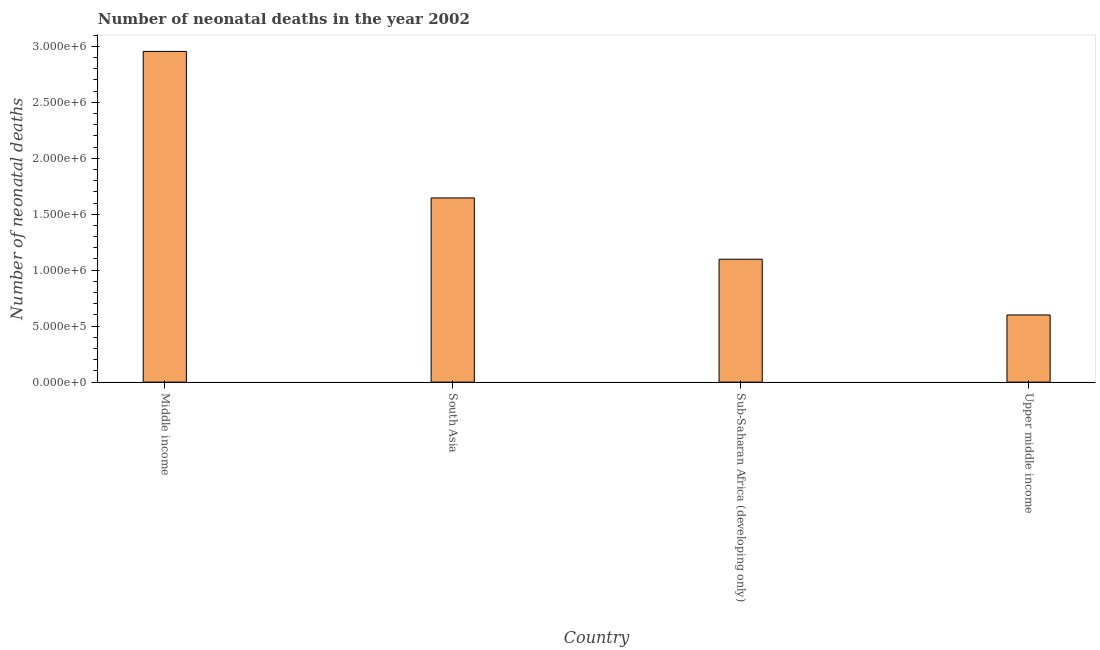Does the graph contain grids?
Your answer should be very brief. No. What is the title of the graph?
Your answer should be compact. Number of neonatal deaths in the year 2002. What is the label or title of the X-axis?
Your answer should be compact. Country. What is the label or title of the Y-axis?
Make the answer very short. Number of neonatal deaths. What is the number of neonatal deaths in Sub-Saharan Africa (developing only)?
Make the answer very short. 1.10e+06. Across all countries, what is the maximum number of neonatal deaths?
Offer a terse response. 2.95e+06. Across all countries, what is the minimum number of neonatal deaths?
Offer a very short reply. 6.00e+05. In which country was the number of neonatal deaths minimum?
Give a very brief answer. Upper middle income. What is the sum of the number of neonatal deaths?
Your response must be concise. 6.30e+06. What is the difference between the number of neonatal deaths in Middle income and Upper middle income?
Give a very brief answer. 2.35e+06. What is the average number of neonatal deaths per country?
Provide a succinct answer. 1.57e+06. What is the median number of neonatal deaths?
Provide a succinct answer. 1.37e+06. What is the ratio of the number of neonatal deaths in Middle income to that in South Asia?
Make the answer very short. 1.8. Is the number of neonatal deaths in Middle income less than that in Upper middle income?
Offer a terse response. No. Is the difference between the number of neonatal deaths in Sub-Saharan Africa (developing only) and Upper middle income greater than the difference between any two countries?
Keep it short and to the point. No. What is the difference between the highest and the second highest number of neonatal deaths?
Your response must be concise. 1.31e+06. What is the difference between the highest and the lowest number of neonatal deaths?
Provide a succinct answer. 2.35e+06. Are all the bars in the graph horizontal?
Your answer should be compact. No. How many countries are there in the graph?
Give a very brief answer. 4. What is the difference between two consecutive major ticks on the Y-axis?
Make the answer very short. 5.00e+05. Are the values on the major ticks of Y-axis written in scientific E-notation?
Ensure brevity in your answer.  Yes. What is the Number of neonatal deaths of Middle income?
Your response must be concise. 2.95e+06. What is the Number of neonatal deaths of South Asia?
Give a very brief answer. 1.65e+06. What is the Number of neonatal deaths in Sub-Saharan Africa (developing only)?
Keep it short and to the point. 1.10e+06. What is the Number of neonatal deaths of Upper middle income?
Your answer should be very brief. 6.00e+05. What is the difference between the Number of neonatal deaths in Middle income and South Asia?
Your response must be concise. 1.31e+06. What is the difference between the Number of neonatal deaths in Middle income and Sub-Saharan Africa (developing only)?
Ensure brevity in your answer.  1.86e+06. What is the difference between the Number of neonatal deaths in Middle income and Upper middle income?
Provide a short and direct response. 2.35e+06. What is the difference between the Number of neonatal deaths in South Asia and Sub-Saharan Africa (developing only)?
Provide a short and direct response. 5.48e+05. What is the difference between the Number of neonatal deaths in South Asia and Upper middle income?
Make the answer very short. 1.05e+06. What is the difference between the Number of neonatal deaths in Sub-Saharan Africa (developing only) and Upper middle income?
Your answer should be compact. 4.98e+05. What is the ratio of the Number of neonatal deaths in Middle income to that in South Asia?
Provide a short and direct response. 1.8. What is the ratio of the Number of neonatal deaths in Middle income to that in Sub-Saharan Africa (developing only)?
Keep it short and to the point. 2.69. What is the ratio of the Number of neonatal deaths in Middle income to that in Upper middle income?
Make the answer very short. 4.92. What is the ratio of the Number of neonatal deaths in South Asia to that in Sub-Saharan Africa (developing only)?
Your response must be concise. 1.5. What is the ratio of the Number of neonatal deaths in South Asia to that in Upper middle income?
Give a very brief answer. 2.74. What is the ratio of the Number of neonatal deaths in Sub-Saharan Africa (developing only) to that in Upper middle income?
Make the answer very short. 1.83. 